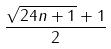<formula> <loc_0><loc_0><loc_500><loc_500>\frac { \sqrt { 2 4 n + 1 } + 1 } { 2 }</formula> 